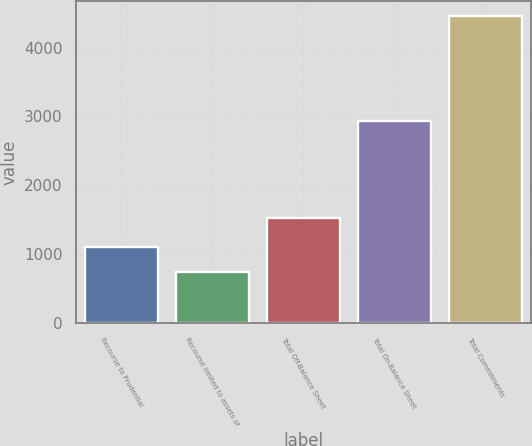Convert chart to OTSL. <chart><loc_0><loc_0><loc_500><loc_500><bar_chart><fcel>Recourse to Prudential<fcel>Recourse limited to assets of<fcel>Total Off-Balance Sheet<fcel>Total On-Balance Sheet<fcel>Total Commitments<nl><fcel>1105.3<fcel>733<fcel>1523<fcel>2933<fcel>4456<nl></chart> 